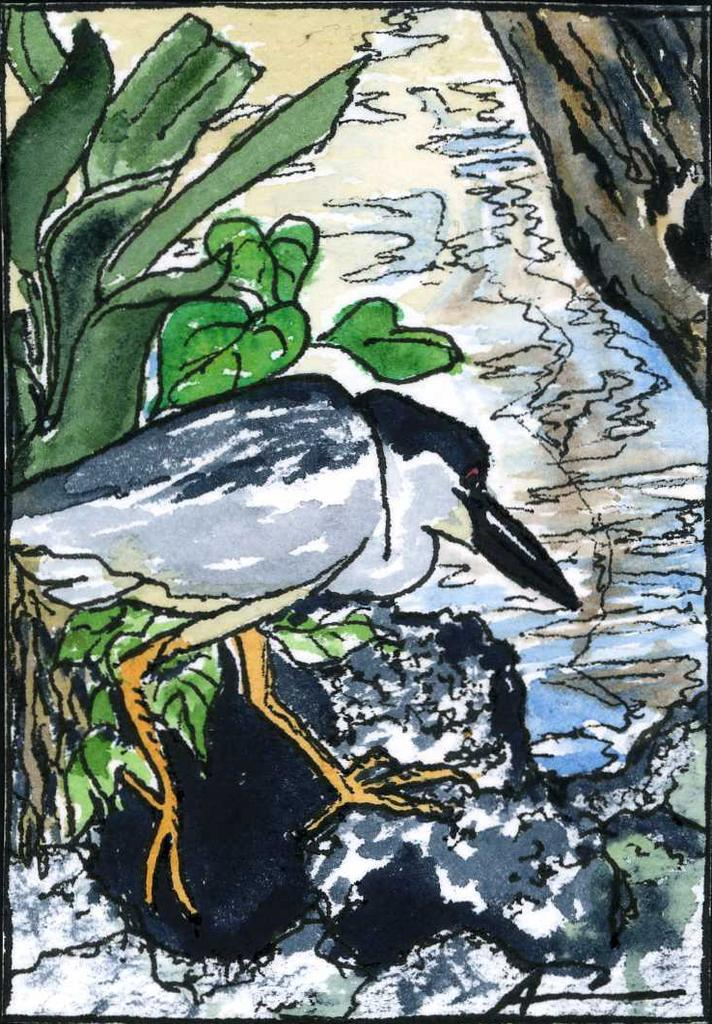What is the main subject of the image? The image contains an art piece. What elements are included in the art piece? The art piece includes a bird and a plant. What type of copper material is used in the art piece? There is no mention of copper in the image or the art piece, so it cannot be determined from the provided information. 